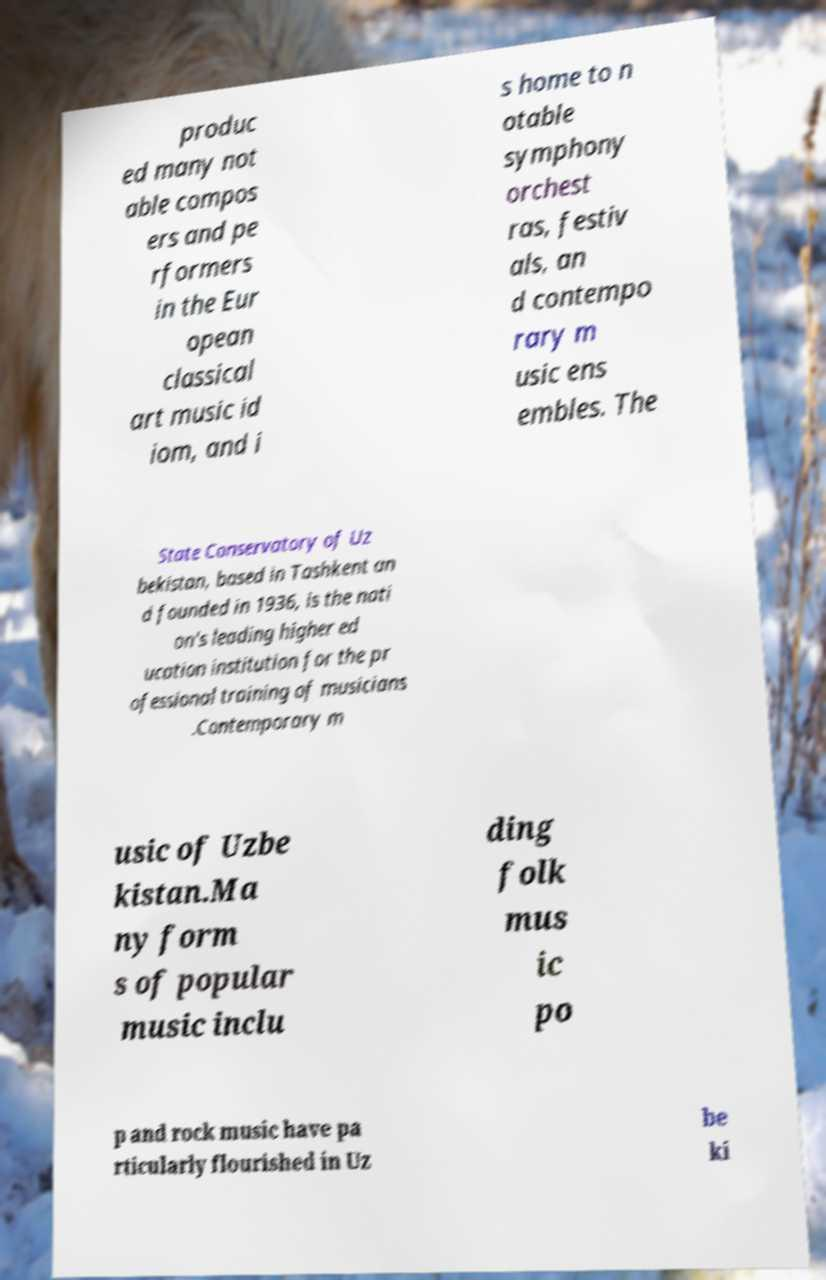There's text embedded in this image that I need extracted. Can you transcribe it verbatim? produc ed many not able compos ers and pe rformers in the Eur opean classical art music id iom, and i s home to n otable symphony orchest ras, festiv als, an d contempo rary m usic ens embles. The State Conservatory of Uz bekistan, based in Tashkent an d founded in 1936, is the nati on's leading higher ed ucation institution for the pr ofessional training of musicians .Contemporary m usic of Uzbe kistan.Ma ny form s of popular music inclu ding folk mus ic po p and rock music have pa rticularly flourished in Uz be ki 